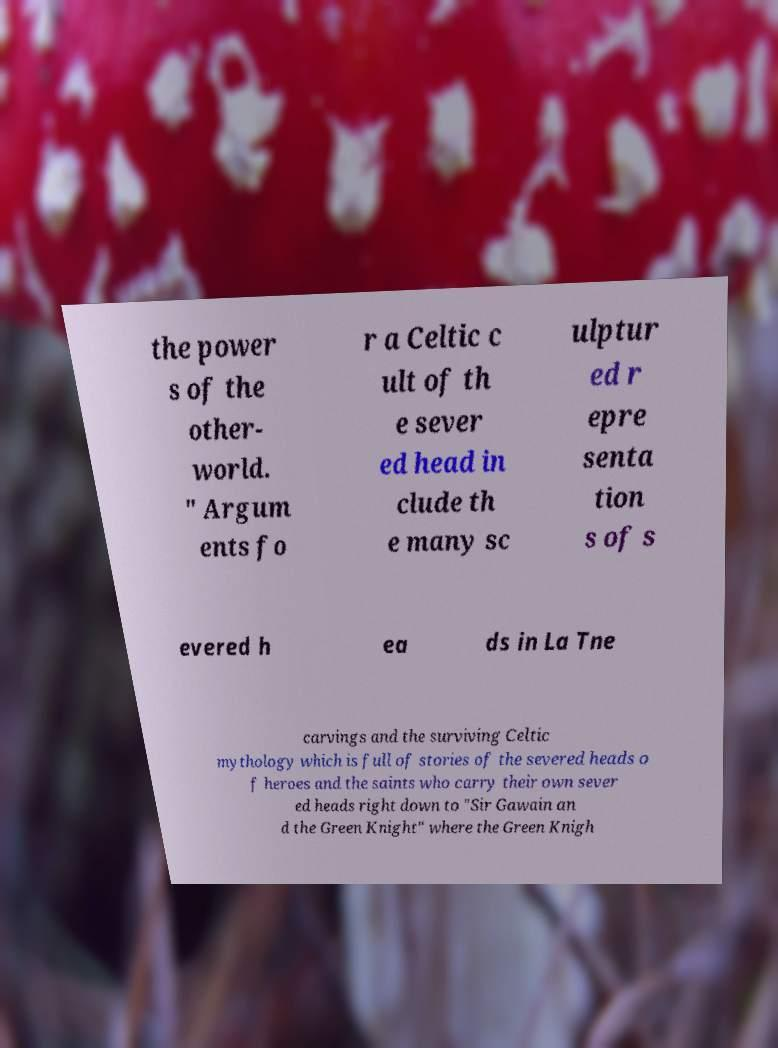Can you accurately transcribe the text from the provided image for me? the power s of the other- world. " Argum ents fo r a Celtic c ult of th e sever ed head in clude th e many sc ulptur ed r epre senta tion s of s evered h ea ds in La Tne carvings and the surviving Celtic mythology which is full of stories of the severed heads o f heroes and the saints who carry their own sever ed heads right down to "Sir Gawain an d the Green Knight" where the Green Knigh 